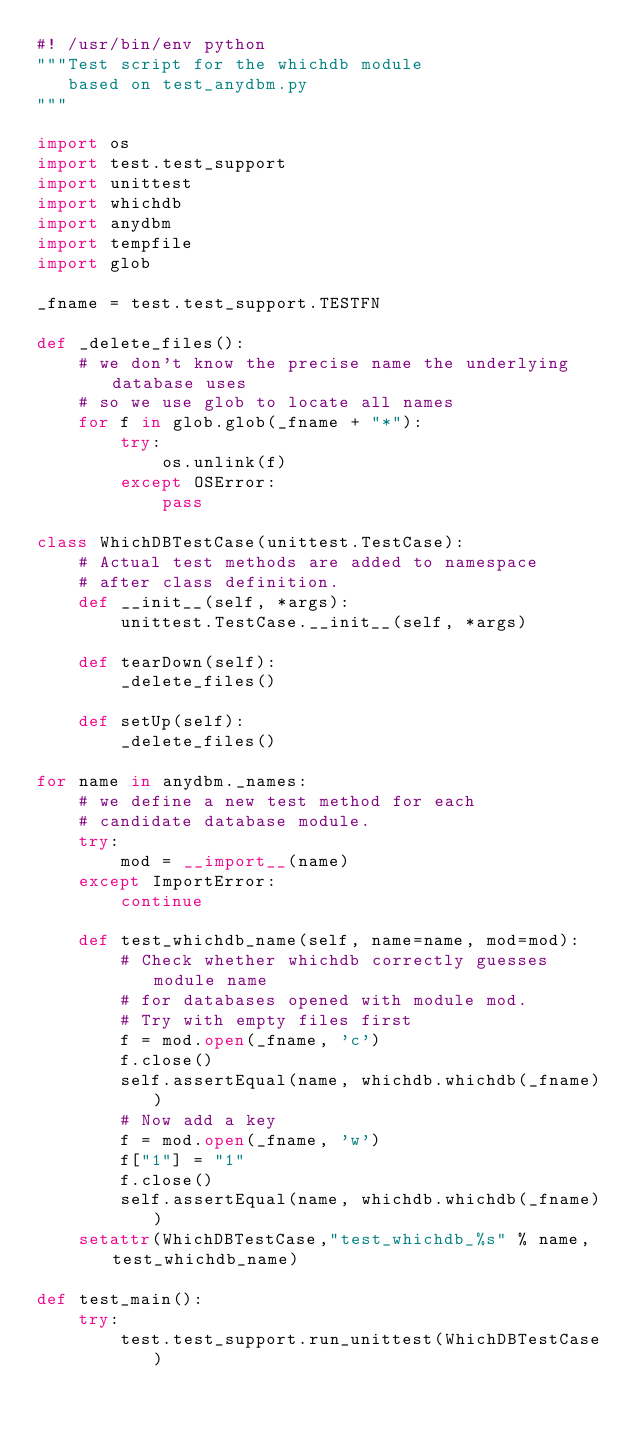<code> <loc_0><loc_0><loc_500><loc_500><_Python_>#! /usr/bin/env python
"""Test script for the whichdb module
   based on test_anydbm.py
"""

import os
import test.test_support
import unittest
import whichdb
import anydbm
import tempfile
import glob

_fname = test.test_support.TESTFN

def _delete_files():
    # we don't know the precise name the underlying database uses
    # so we use glob to locate all names
    for f in glob.glob(_fname + "*"):
        try:
            os.unlink(f)
        except OSError:
            pass

class WhichDBTestCase(unittest.TestCase):
    # Actual test methods are added to namespace
    # after class definition.
    def __init__(self, *args):
        unittest.TestCase.__init__(self, *args)

    def tearDown(self):
        _delete_files()

    def setUp(self):
        _delete_files()

for name in anydbm._names:
    # we define a new test method for each
    # candidate database module.
    try:
        mod = __import__(name)
    except ImportError:
        continue

    def test_whichdb_name(self, name=name, mod=mod):
        # Check whether whichdb correctly guesses module name
        # for databases opened with module mod.
        # Try with empty files first
        f = mod.open(_fname, 'c')
        f.close()
        self.assertEqual(name, whichdb.whichdb(_fname))
        # Now add a key
        f = mod.open(_fname, 'w')
        f["1"] = "1"
        f.close()
        self.assertEqual(name, whichdb.whichdb(_fname))
    setattr(WhichDBTestCase,"test_whichdb_%s" % name, test_whichdb_name)

def test_main():
    try:
        test.test_support.run_unittest(WhichDBTestCase)</code> 